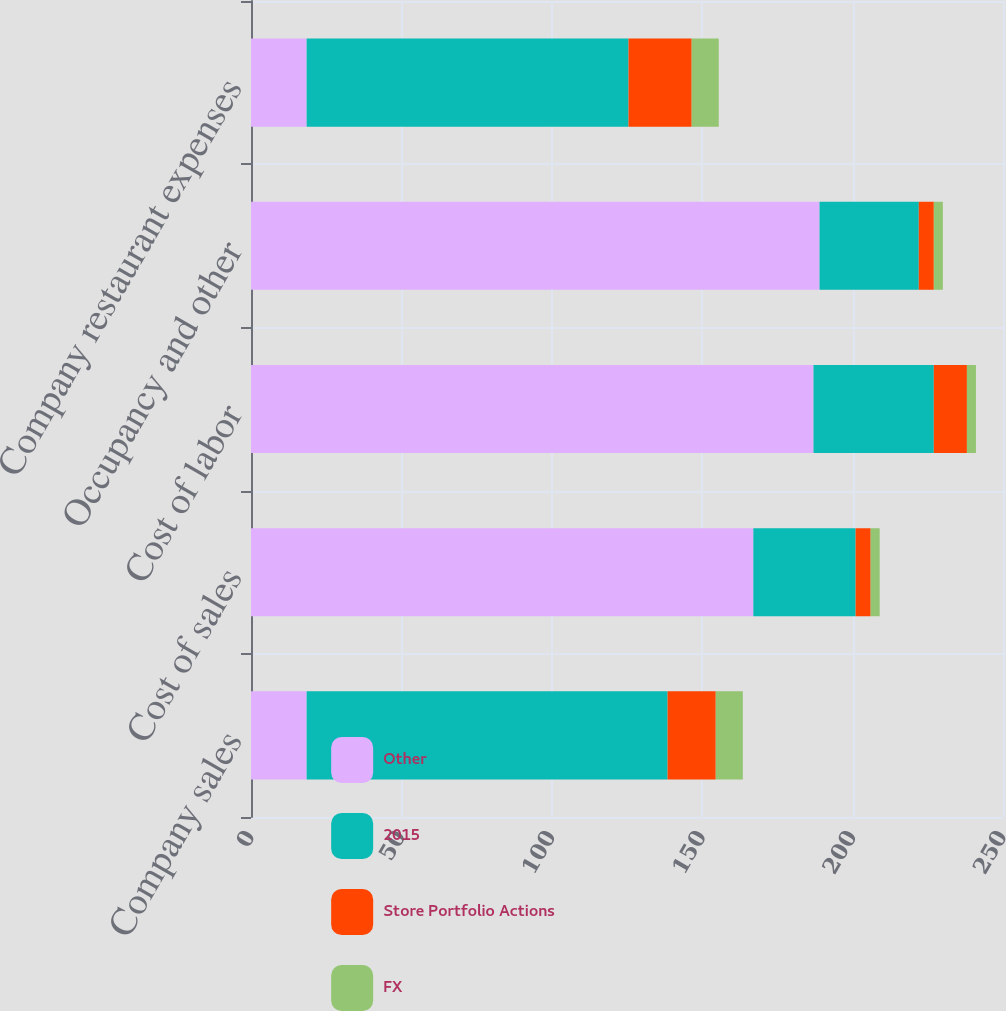Convert chart. <chart><loc_0><loc_0><loc_500><loc_500><stacked_bar_chart><ecel><fcel>Company sales<fcel>Cost of sales<fcel>Cost of labor<fcel>Occupancy and other<fcel>Company restaurant expenses<nl><fcel>Other<fcel>18.5<fcel>167<fcel>187<fcel>189<fcel>18.5<nl><fcel>2015<fcel>120<fcel>34<fcel>40<fcel>33<fcel>107<nl><fcel>Store Portfolio Actions<fcel>16<fcel>5<fcel>11<fcel>5<fcel>21<nl><fcel>FX<fcel>9<fcel>3<fcel>3<fcel>3<fcel>9<nl></chart> 